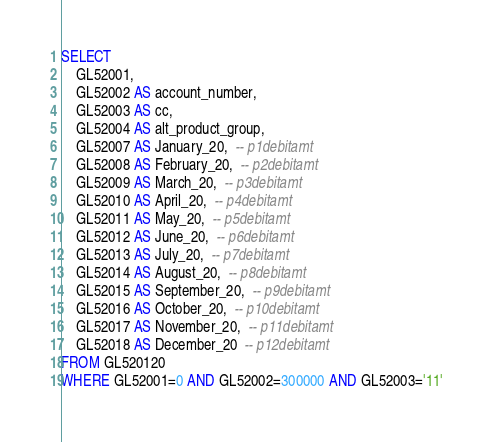<code> <loc_0><loc_0><loc_500><loc_500><_SQL_>SELECT
	GL52001,
	GL52002 AS account_number,
	GL52003 AS cc,
	GL52004 AS alt_product_group,
	GL52007 AS January_20,  -- p1debitamt
	GL52008 AS February_20,  -- p2debitamt
	GL52009 AS March_20,  -- p3debitamt
	GL52010 AS April_20,  -- p4debitamt
	GL52011 AS May_20,  -- p5debitamt
	GL52012 AS June_20,  -- p6debitamt
	GL52013 AS July_20,  -- p7debitamt
	GL52014 AS August_20,  -- p8debitamt
	GL52015 AS September_20,  -- p9debitamt
	GL52016 AS October_20,  -- p10debitamt
	GL52017 AS November_20,  -- p11debitamt
	GL52018 AS December_20  -- p12debitamt
FROM GL520120
WHERE GL52001=0 AND GL52002=300000 AND GL52003='11'
</code> 